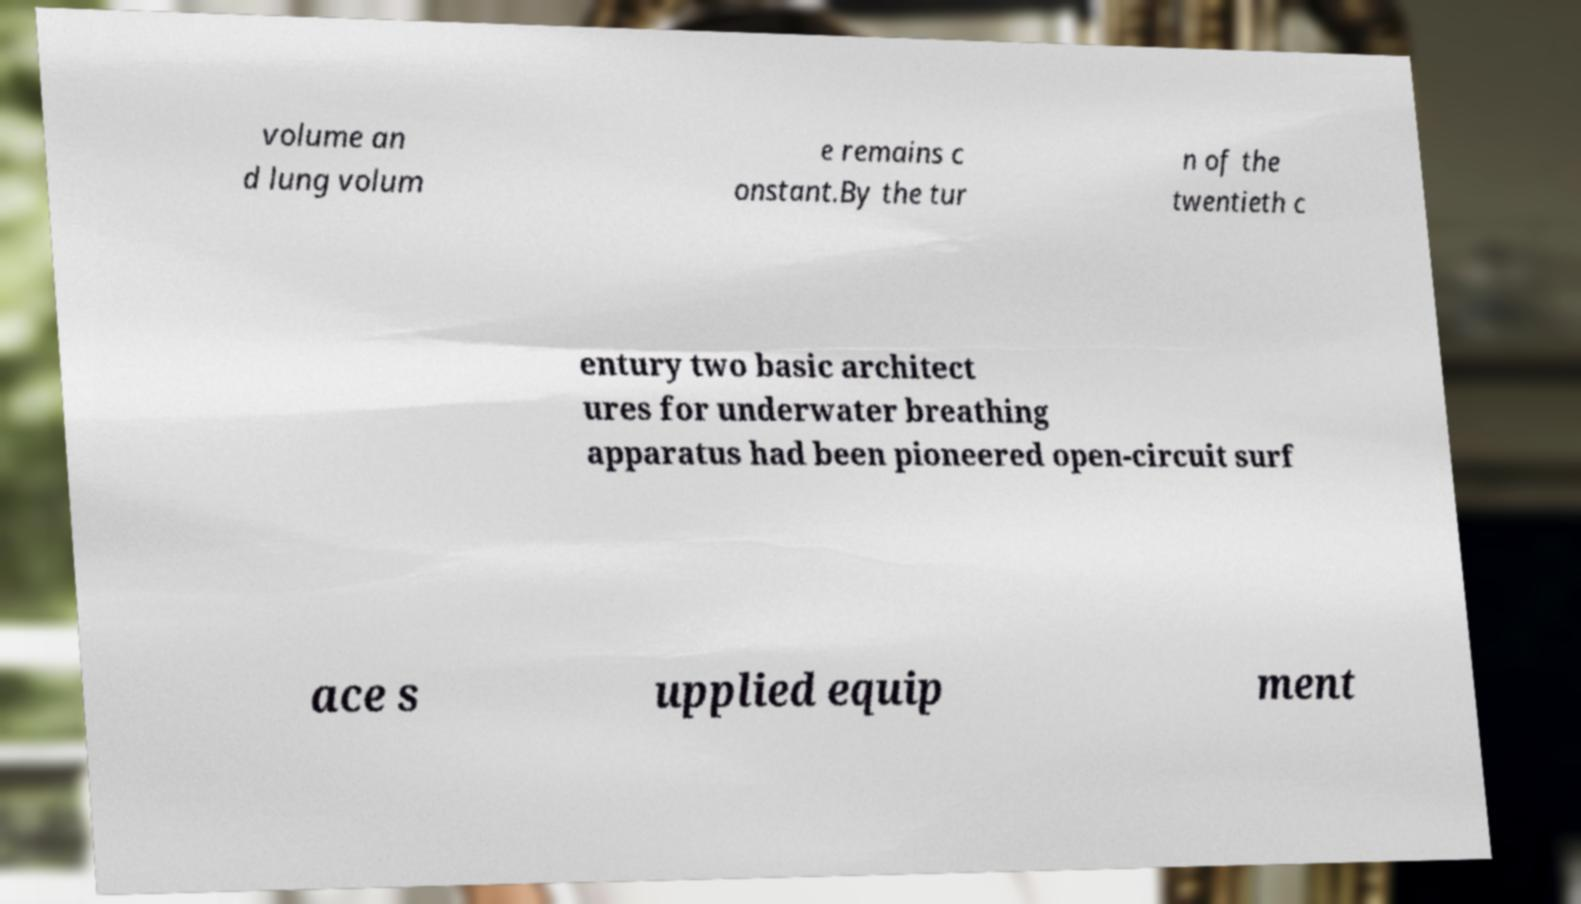Please read and relay the text visible in this image. What does it say? volume an d lung volum e remains c onstant.By the tur n of the twentieth c entury two basic architect ures for underwater breathing apparatus had been pioneered open-circuit surf ace s upplied equip ment 